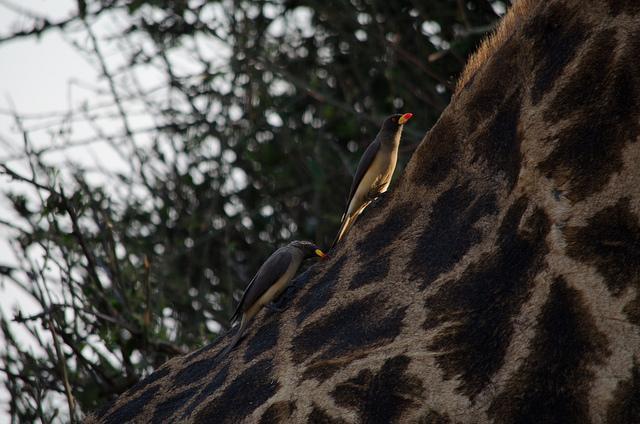Where are the birds standing on?
Answer the question by selecting the correct answer among the 4 following choices.
Options: Giraffe, carpet, tree, blanket. Giraffe. 